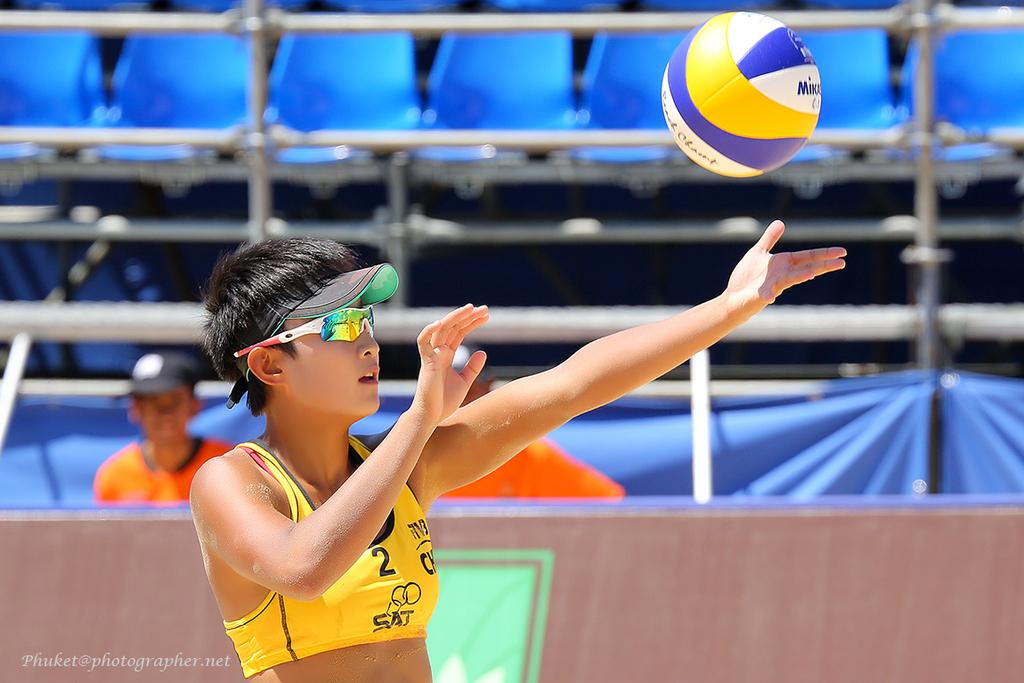<image>
Give a short and clear explanation of the subsequent image. A woman in a yellow sports bra with the number 2 on it is playing volleyball. 